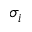Convert formula to latex. <formula><loc_0><loc_0><loc_500><loc_500>\sigma _ { i }</formula> 